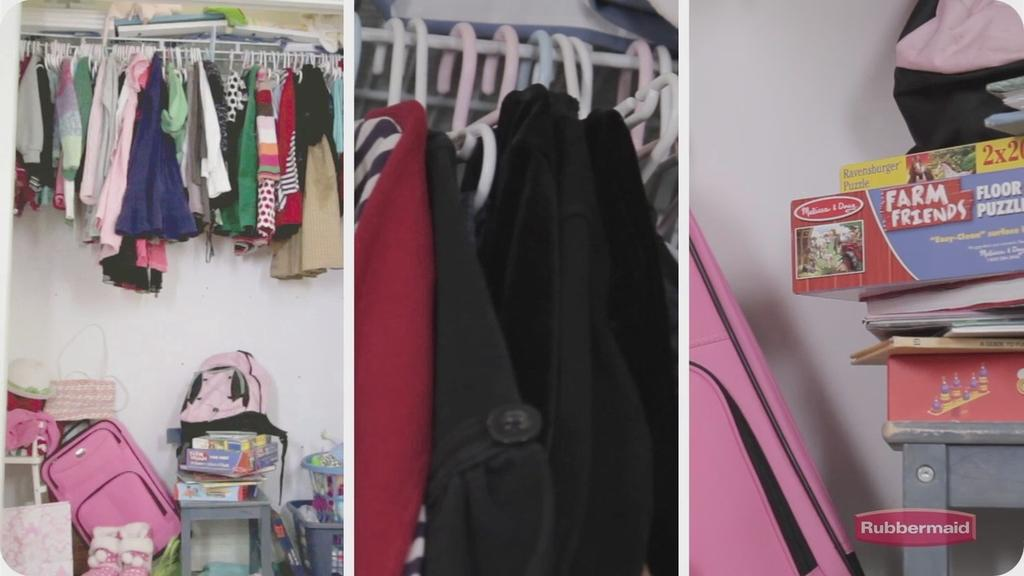Provide a one-sentence caption for the provided image. Farm Friends is the name of the game stored away in the closet. 